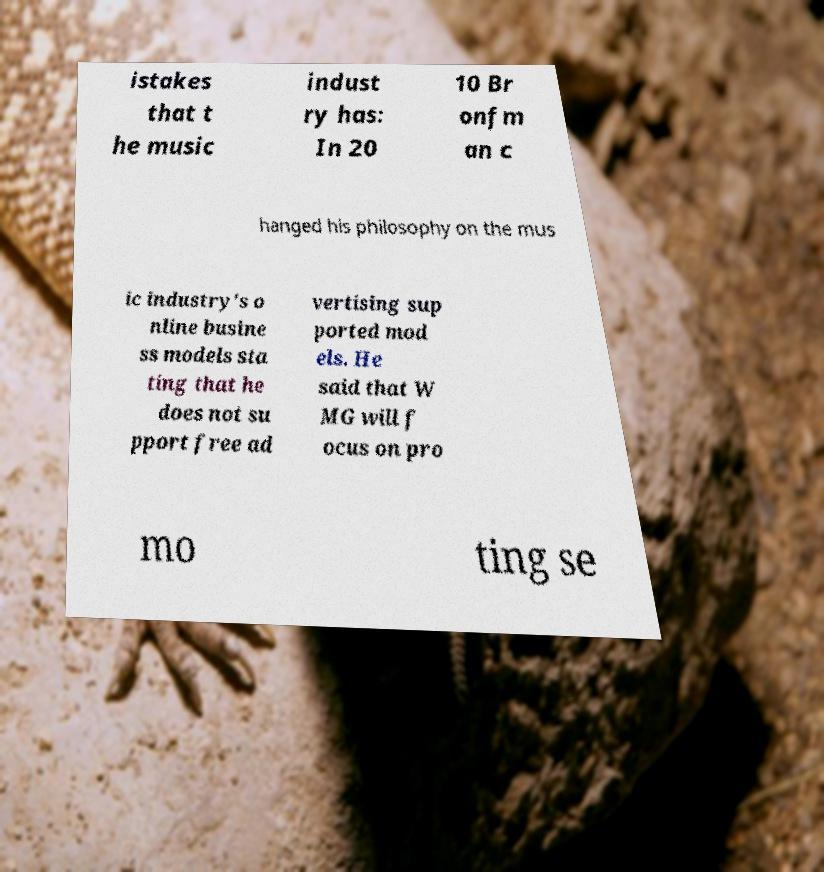For documentation purposes, I need the text within this image transcribed. Could you provide that? istakes that t he music indust ry has: In 20 10 Br onfm an c hanged his philosophy on the mus ic industry's o nline busine ss models sta ting that he does not su pport free ad vertising sup ported mod els. He said that W MG will f ocus on pro mo ting se 